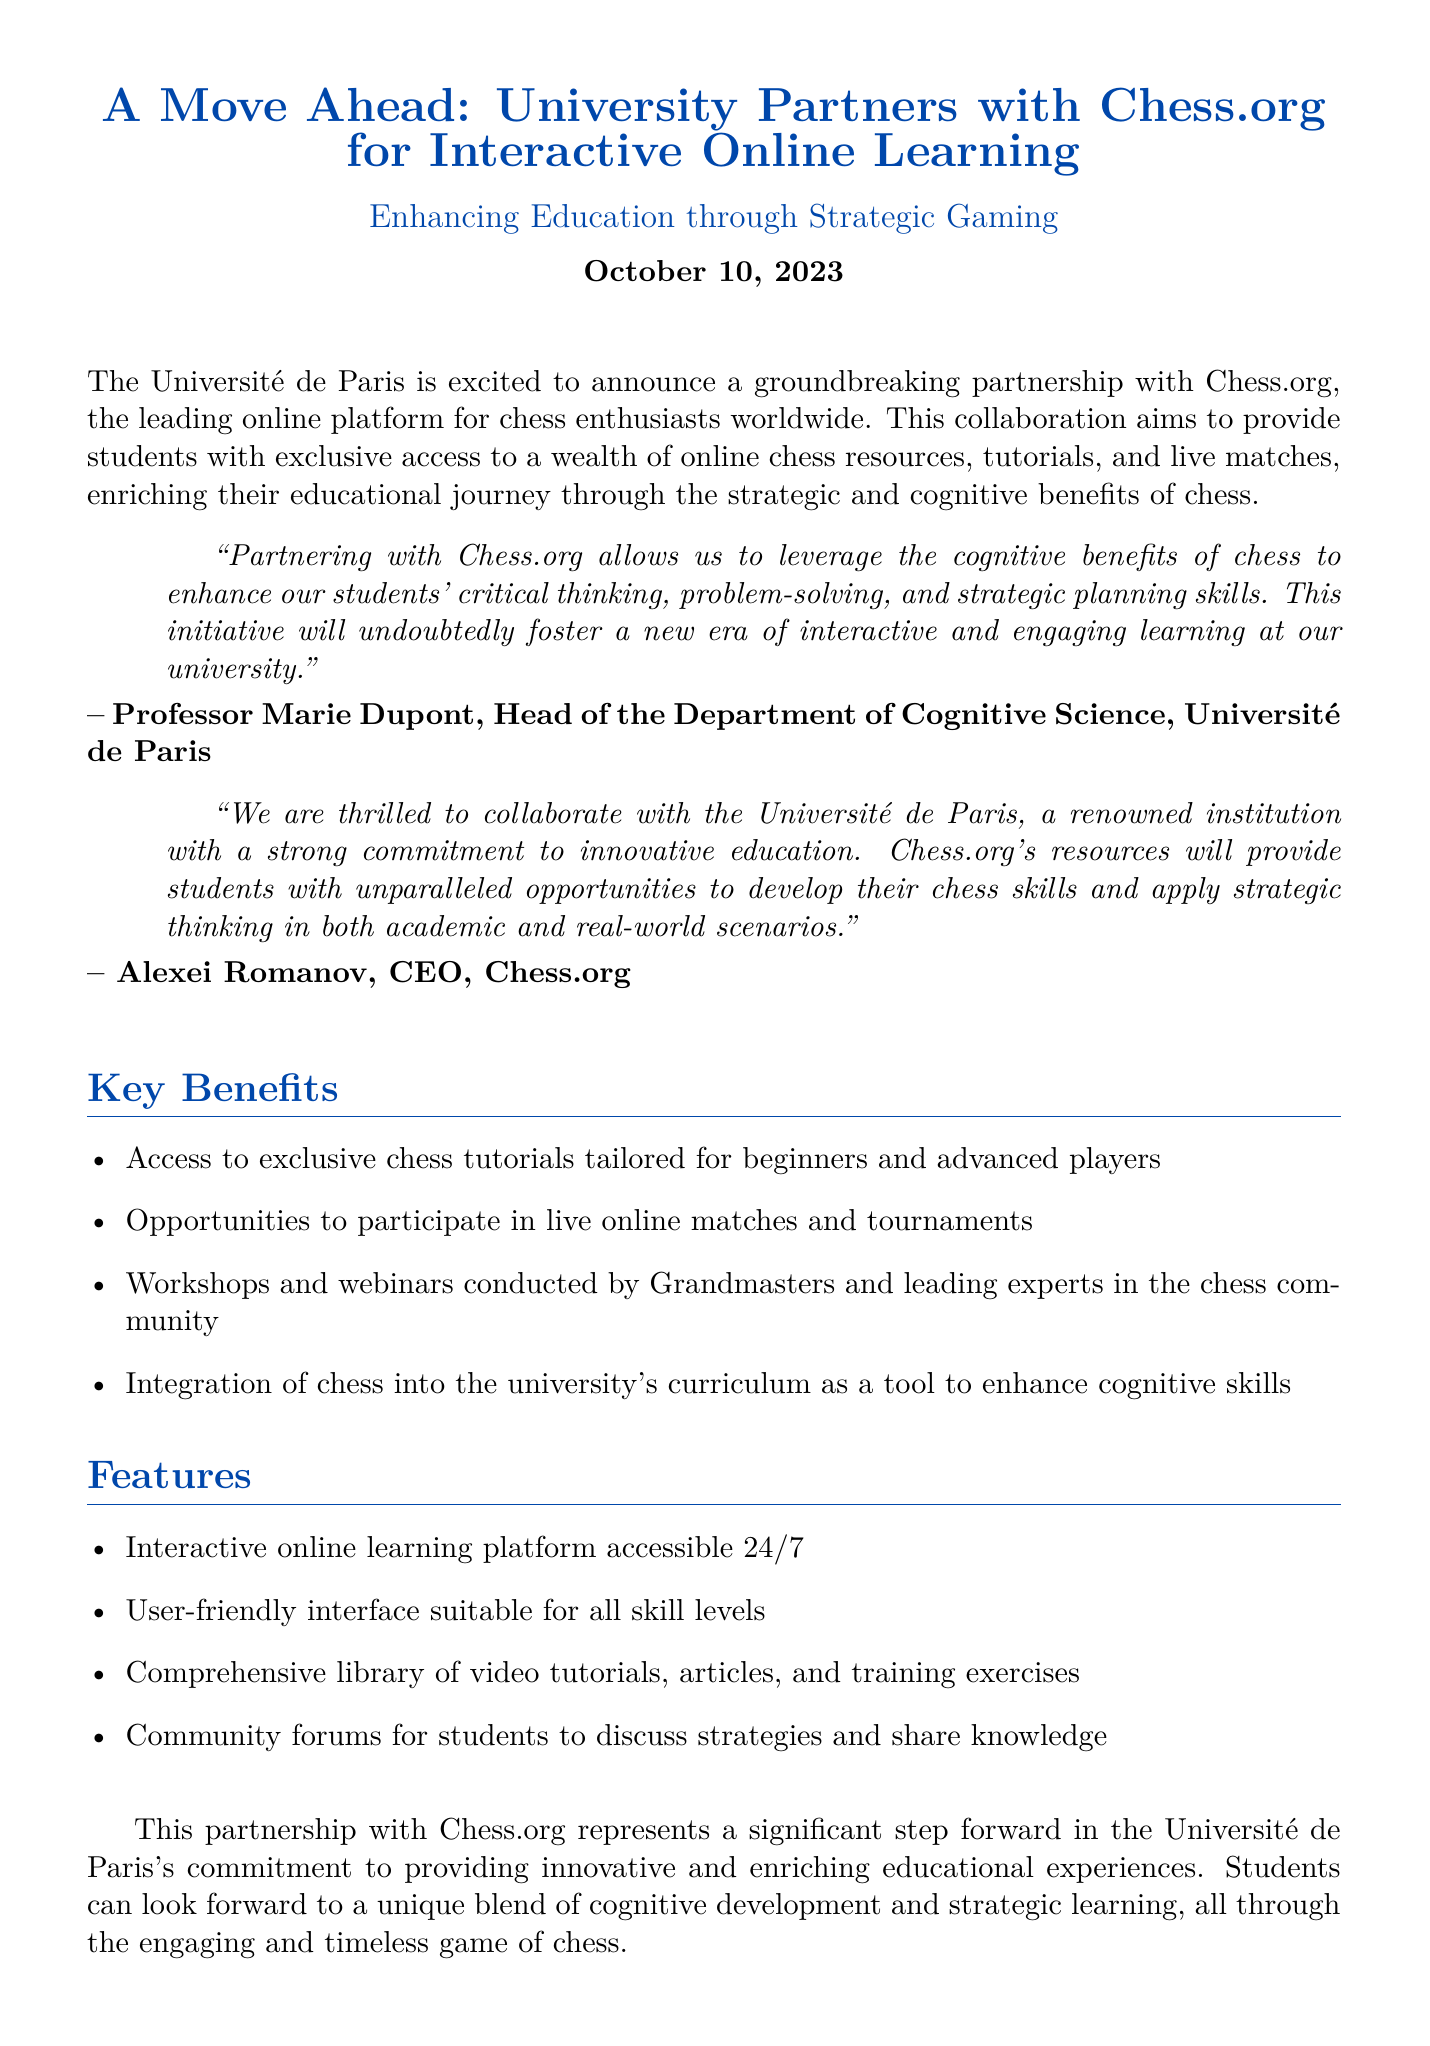What is the name of the university partnering with Chess.org? The university partnering with Chess.org is the Université de Paris.
Answer: Université de Paris Who is the Head of the Department of Cognitive Science at the university? The Head of the Department of Cognitive Science at the university is Professor Marie Dupont.
Answer: Professor Marie Dupont What date was the partnership announced? The partnership was announced on October 10, 2023.
Answer: October 10, 2023 What is one of the key benefits of the partnership? One of the key benefits is access to exclusive chess tutorials tailored for beginners and advanced players.
Answer: Exclusive chess tutorials Who is the CEO of Chess.org? The CEO of Chess.org is Alexei Romanov.
Answer: Alexei Romanov What type of platform will students have access to? Students will have access to an interactive online learning platform.
Answer: Interactive online learning platform What will the partnership enhance in students according to the press release? The partnership will enhance students' critical thinking, problem-solving, and strategic planning skills.
Answer: Critical thinking, problem-solving, and strategic planning skills What will the university integrate into its curriculum? The university will integrate chess into its curriculum as a tool to enhance cognitive skills.
Answer: Chess What role does Sophia Fields hold at Chess.org? Sophia Fields is the Public Relations Manager at Chess.org.
Answer: Public Relations Manager 